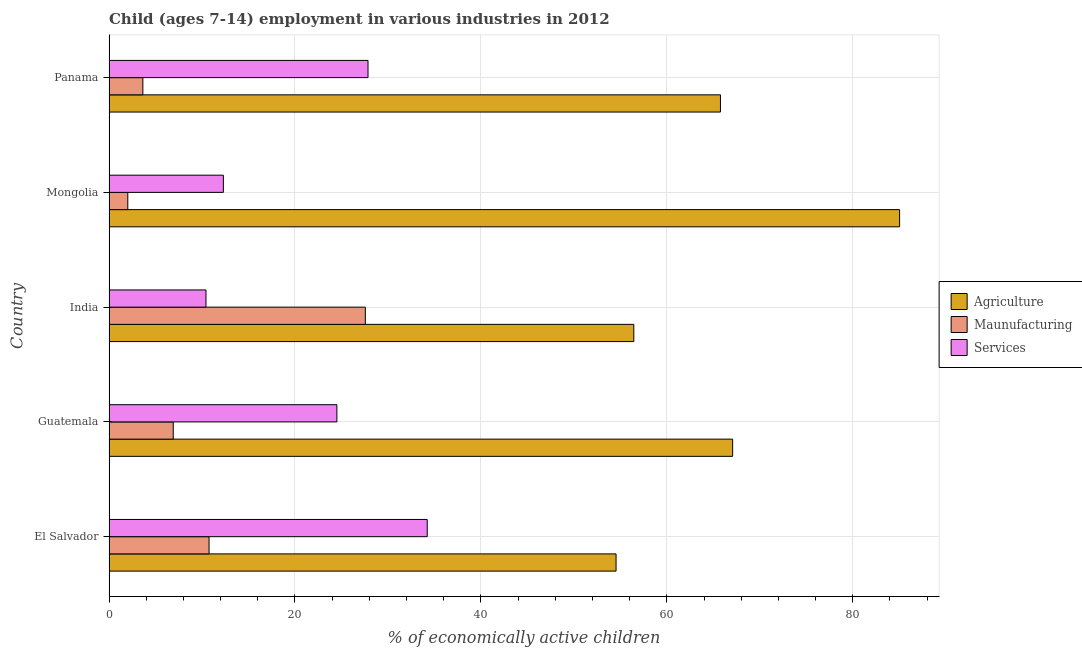How many groups of bars are there?
Your answer should be compact. 5. Are the number of bars per tick equal to the number of legend labels?
Provide a short and direct response. Yes. Are the number of bars on each tick of the Y-axis equal?
Offer a terse response. Yes. How many bars are there on the 1st tick from the top?
Make the answer very short. 3. How many bars are there on the 2nd tick from the bottom?
Provide a succinct answer. 3. What is the label of the 1st group of bars from the top?
Offer a terse response. Panama. In how many cases, is the number of bars for a given country not equal to the number of legend labels?
Offer a very short reply. 0. What is the percentage of economically active children in agriculture in Panama?
Your answer should be very brief. 65.77. Across all countries, what is the maximum percentage of economically active children in services?
Give a very brief answer. 34.23. Across all countries, what is the minimum percentage of economically active children in services?
Your response must be concise. 10.43. In which country was the percentage of economically active children in manufacturing maximum?
Your answer should be compact. India. In which country was the percentage of economically active children in services minimum?
Your answer should be compact. India. What is the total percentage of economically active children in agriculture in the graph?
Give a very brief answer. 328.88. What is the difference between the percentage of economically active children in services in India and that in Mongolia?
Your response must be concise. -1.87. What is the difference between the percentage of economically active children in services in Panama and the percentage of economically active children in manufacturing in Guatemala?
Your response must be concise. 20.95. What is the average percentage of economically active children in services per country?
Your answer should be compact. 21.87. What is the difference between the percentage of economically active children in agriculture and percentage of economically active children in manufacturing in India?
Provide a succinct answer. 28.88. In how many countries, is the percentage of economically active children in manufacturing greater than 36 %?
Offer a terse response. 0. What is the ratio of the percentage of economically active children in manufacturing in Guatemala to that in Panama?
Your answer should be compact. 1.9. Is the difference between the percentage of economically active children in agriculture in Guatemala and Mongolia greater than the difference between the percentage of economically active children in services in Guatemala and Mongolia?
Your answer should be very brief. No. What is the difference between the highest and the second highest percentage of economically active children in services?
Offer a very short reply. 6.37. What is the difference between the highest and the lowest percentage of economically active children in agriculture?
Your answer should be very brief. 30.5. In how many countries, is the percentage of economically active children in agriculture greater than the average percentage of economically active children in agriculture taken over all countries?
Offer a very short reply. 2. What does the 2nd bar from the top in Mongolia represents?
Provide a succinct answer. Maunufacturing. What does the 1st bar from the bottom in Guatemala represents?
Your response must be concise. Agriculture. Is it the case that in every country, the sum of the percentage of economically active children in agriculture and percentage of economically active children in manufacturing is greater than the percentage of economically active children in services?
Give a very brief answer. Yes. Are the values on the major ticks of X-axis written in scientific E-notation?
Your answer should be compact. No. Does the graph contain any zero values?
Your answer should be very brief. No. Does the graph contain grids?
Keep it short and to the point. Yes. Where does the legend appear in the graph?
Make the answer very short. Center right. How many legend labels are there?
Keep it short and to the point. 3. What is the title of the graph?
Make the answer very short. Child (ages 7-14) employment in various industries in 2012. Does "Coal" appear as one of the legend labels in the graph?
Give a very brief answer. No. What is the label or title of the X-axis?
Offer a terse response. % of economically active children. What is the label or title of the Y-axis?
Make the answer very short. Country. What is the % of economically active children of Agriculture in El Salvador?
Keep it short and to the point. 54.54. What is the % of economically active children in Maunufacturing in El Salvador?
Make the answer very short. 10.76. What is the % of economically active children in Services in El Salvador?
Offer a terse response. 34.23. What is the % of economically active children of Agriculture in Guatemala?
Keep it short and to the point. 67.08. What is the % of economically active children in Maunufacturing in Guatemala?
Give a very brief answer. 6.91. What is the % of economically active children in Services in Guatemala?
Provide a succinct answer. 24.51. What is the % of economically active children of Agriculture in India?
Ensure brevity in your answer.  56.45. What is the % of economically active children in Maunufacturing in India?
Ensure brevity in your answer.  27.57. What is the % of economically active children of Services in India?
Offer a very short reply. 10.43. What is the % of economically active children of Agriculture in Mongolia?
Your answer should be compact. 85.04. What is the % of economically active children of Maunufacturing in Mongolia?
Provide a succinct answer. 2.02. What is the % of economically active children in Services in Mongolia?
Make the answer very short. 12.3. What is the % of economically active children of Agriculture in Panama?
Offer a very short reply. 65.77. What is the % of economically active children in Maunufacturing in Panama?
Provide a succinct answer. 3.64. What is the % of economically active children in Services in Panama?
Give a very brief answer. 27.86. Across all countries, what is the maximum % of economically active children of Agriculture?
Your answer should be compact. 85.04. Across all countries, what is the maximum % of economically active children of Maunufacturing?
Provide a short and direct response. 27.57. Across all countries, what is the maximum % of economically active children in Services?
Ensure brevity in your answer.  34.23. Across all countries, what is the minimum % of economically active children in Agriculture?
Keep it short and to the point. 54.54. Across all countries, what is the minimum % of economically active children of Maunufacturing?
Provide a succinct answer. 2.02. Across all countries, what is the minimum % of economically active children of Services?
Your answer should be very brief. 10.43. What is the total % of economically active children of Agriculture in the graph?
Provide a short and direct response. 328.88. What is the total % of economically active children of Maunufacturing in the graph?
Give a very brief answer. 50.9. What is the total % of economically active children of Services in the graph?
Offer a terse response. 109.33. What is the difference between the % of economically active children in Agriculture in El Salvador and that in Guatemala?
Offer a terse response. -12.54. What is the difference between the % of economically active children in Maunufacturing in El Salvador and that in Guatemala?
Give a very brief answer. 3.85. What is the difference between the % of economically active children of Services in El Salvador and that in Guatemala?
Give a very brief answer. 9.72. What is the difference between the % of economically active children of Agriculture in El Salvador and that in India?
Make the answer very short. -1.91. What is the difference between the % of economically active children of Maunufacturing in El Salvador and that in India?
Your response must be concise. -16.81. What is the difference between the % of economically active children in Services in El Salvador and that in India?
Your answer should be compact. 23.8. What is the difference between the % of economically active children in Agriculture in El Salvador and that in Mongolia?
Ensure brevity in your answer.  -30.5. What is the difference between the % of economically active children of Maunufacturing in El Salvador and that in Mongolia?
Keep it short and to the point. 8.74. What is the difference between the % of economically active children of Services in El Salvador and that in Mongolia?
Keep it short and to the point. 21.93. What is the difference between the % of economically active children in Agriculture in El Salvador and that in Panama?
Offer a terse response. -11.23. What is the difference between the % of economically active children of Maunufacturing in El Salvador and that in Panama?
Your answer should be very brief. 7.12. What is the difference between the % of economically active children in Services in El Salvador and that in Panama?
Your answer should be very brief. 6.37. What is the difference between the % of economically active children of Agriculture in Guatemala and that in India?
Make the answer very short. 10.63. What is the difference between the % of economically active children in Maunufacturing in Guatemala and that in India?
Ensure brevity in your answer.  -20.66. What is the difference between the % of economically active children in Services in Guatemala and that in India?
Ensure brevity in your answer.  14.08. What is the difference between the % of economically active children in Agriculture in Guatemala and that in Mongolia?
Your response must be concise. -17.96. What is the difference between the % of economically active children of Maunufacturing in Guatemala and that in Mongolia?
Your response must be concise. 4.89. What is the difference between the % of economically active children of Services in Guatemala and that in Mongolia?
Offer a very short reply. 12.21. What is the difference between the % of economically active children in Agriculture in Guatemala and that in Panama?
Make the answer very short. 1.31. What is the difference between the % of economically active children of Maunufacturing in Guatemala and that in Panama?
Keep it short and to the point. 3.27. What is the difference between the % of economically active children in Services in Guatemala and that in Panama?
Keep it short and to the point. -3.35. What is the difference between the % of economically active children in Agriculture in India and that in Mongolia?
Provide a succinct answer. -28.59. What is the difference between the % of economically active children in Maunufacturing in India and that in Mongolia?
Offer a very short reply. 25.55. What is the difference between the % of economically active children in Services in India and that in Mongolia?
Keep it short and to the point. -1.87. What is the difference between the % of economically active children of Agriculture in India and that in Panama?
Your response must be concise. -9.32. What is the difference between the % of economically active children in Maunufacturing in India and that in Panama?
Give a very brief answer. 23.93. What is the difference between the % of economically active children in Services in India and that in Panama?
Give a very brief answer. -17.43. What is the difference between the % of economically active children in Agriculture in Mongolia and that in Panama?
Provide a short and direct response. 19.27. What is the difference between the % of economically active children of Maunufacturing in Mongolia and that in Panama?
Your answer should be compact. -1.62. What is the difference between the % of economically active children in Services in Mongolia and that in Panama?
Your answer should be very brief. -15.56. What is the difference between the % of economically active children of Agriculture in El Salvador and the % of economically active children of Maunufacturing in Guatemala?
Give a very brief answer. 47.63. What is the difference between the % of economically active children in Agriculture in El Salvador and the % of economically active children in Services in Guatemala?
Keep it short and to the point. 30.03. What is the difference between the % of economically active children in Maunufacturing in El Salvador and the % of economically active children in Services in Guatemala?
Your response must be concise. -13.75. What is the difference between the % of economically active children of Agriculture in El Salvador and the % of economically active children of Maunufacturing in India?
Your answer should be compact. 26.97. What is the difference between the % of economically active children of Agriculture in El Salvador and the % of economically active children of Services in India?
Keep it short and to the point. 44.11. What is the difference between the % of economically active children of Maunufacturing in El Salvador and the % of economically active children of Services in India?
Make the answer very short. 0.33. What is the difference between the % of economically active children of Agriculture in El Salvador and the % of economically active children of Maunufacturing in Mongolia?
Make the answer very short. 52.52. What is the difference between the % of economically active children in Agriculture in El Salvador and the % of economically active children in Services in Mongolia?
Your answer should be very brief. 42.24. What is the difference between the % of economically active children in Maunufacturing in El Salvador and the % of economically active children in Services in Mongolia?
Your answer should be compact. -1.54. What is the difference between the % of economically active children of Agriculture in El Salvador and the % of economically active children of Maunufacturing in Panama?
Provide a short and direct response. 50.9. What is the difference between the % of economically active children in Agriculture in El Salvador and the % of economically active children in Services in Panama?
Offer a very short reply. 26.68. What is the difference between the % of economically active children in Maunufacturing in El Salvador and the % of economically active children in Services in Panama?
Your answer should be compact. -17.1. What is the difference between the % of economically active children of Agriculture in Guatemala and the % of economically active children of Maunufacturing in India?
Keep it short and to the point. 39.51. What is the difference between the % of economically active children in Agriculture in Guatemala and the % of economically active children in Services in India?
Your answer should be compact. 56.65. What is the difference between the % of economically active children of Maunufacturing in Guatemala and the % of economically active children of Services in India?
Your answer should be very brief. -3.52. What is the difference between the % of economically active children in Agriculture in Guatemala and the % of economically active children in Maunufacturing in Mongolia?
Your answer should be very brief. 65.06. What is the difference between the % of economically active children in Agriculture in Guatemala and the % of economically active children in Services in Mongolia?
Keep it short and to the point. 54.78. What is the difference between the % of economically active children in Maunufacturing in Guatemala and the % of economically active children in Services in Mongolia?
Offer a terse response. -5.39. What is the difference between the % of economically active children of Agriculture in Guatemala and the % of economically active children of Maunufacturing in Panama?
Keep it short and to the point. 63.44. What is the difference between the % of economically active children of Agriculture in Guatemala and the % of economically active children of Services in Panama?
Offer a very short reply. 39.22. What is the difference between the % of economically active children of Maunufacturing in Guatemala and the % of economically active children of Services in Panama?
Your answer should be compact. -20.95. What is the difference between the % of economically active children in Agriculture in India and the % of economically active children in Maunufacturing in Mongolia?
Keep it short and to the point. 54.43. What is the difference between the % of economically active children in Agriculture in India and the % of economically active children in Services in Mongolia?
Provide a short and direct response. 44.15. What is the difference between the % of economically active children of Maunufacturing in India and the % of economically active children of Services in Mongolia?
Ensure brevity in your answer.  15.27. What is the difference between the % of economically active children in Agriculture in India and the % of economically active children in Maunufacturing in Panama?
Offer a terse response. 52.81. What is the difference between the % of economically active children of Agriculture in India and the % of economically active children of Services in Panama?
Ensure brevity in your answer.  28.59. What is the difference between the % of economically active children of Maunufacturing in India and the % of economically active children of Services in Panama?
Keep it short and to the point. -0.29. What is the difference between the % of economically active children of Agriculture in Mongolia and the % of economically active children of Maunufacturing in Panama?
Provide a succinct answer. 81.4. What is the difference between the % of economically active children of Agriculture in Mongolia and the % of economically active children of Services in Panama?
Your answer should be compact. 57.18. What is the difference between the % of economically active children of Maunufacturing in Mongolia and the % of economically active children of Services in Panama?
Offer a terse response. -25.84. What is the average % of economically active children of Agriculture per country?
Give a very brief answer. 65.78. What is the average % of economically active children in Maunufacturing per country?
Your answer should be very brief. 10.18. What is the average % of economically active children of Services per country?
Provide a short and direct response. 21.87. What is the difference between the % of economically active children in Agriculture and % of economically active children in Maunufacturing in El Salvador?
Ensure brevity in your answer.  43.78. What is the difference between the % of economically active children in Agriculture and % of economically active children in Services in El Salvador?
Provide a short and direct response. 20.31. What is the difference between the % of economically active children of Maunufacturing and % of economically active children of Services in El Salvador?
Provide a succinct answer. -23.47. What is the difference between the % of economically active children of Agriculture and % of economically active children of Maunufacturing in Guatemala?
Provide a succinct answer. 60.17. What is the difference between the % of economically active children in Agriculture and % of economically active children in Services in Guatemala?
Provide a succinct answer. 42.57. What is the difference between the % of economically active children in Maunufacturing and % of economically active children in Services in Guatemala?
Offer a terse response. -17.6. What is the difference between the % of economically active children of Agriculture and % of economically active children of Maunufacturing in India?
Provide a succinct answer. 28.88. What is the difference between the % of economically active children in Agriculture and % of economically active children in Services in India?
Offer a terse response. 46.02. What is the difference between the % of economically active children of Maunufacturing and % of economically active children of Services in India?
Keep it short and to the point. 17.14. What is the difference between the % of economically active children in Agriculture and % of economically active children in Maunufacturing in Mongolia?
Ensure brevity in your answer.  83.02. What is the difference between the % of economically active children of Agriculture and % of economically active children of Services in Mongolia?
Offer a very short reply. 72.74. What is the difference between the % of economically active children in Maunufacturing and % of economically active children in Services in Mongolia?
Make the answer very short. -10.28. What is the difference between the % of economically active children of Agriculture and % of economically active children of Maunufacturing in Panama?
Your answer should be very brief. 62.13. What is the difference between the % of economically active children in Agriculture and % of economically active children in Services in Panama?
Give a very brief answer. 37.91. What is the difference between the % of economically active children in Maunufacturing and % of economically active children in Services in Panama?
Provide a short and direct response. -24.22. What is the ratio of the % of economically active children in Agriculture in El Salvador to that in Guatemala?
Provide a short and direct response. 0.81. What is the ratio of the % of economically active children in Maunufacturing in El Salvador to that in Guatemala?
Make the answer very short. 1.56. What is the ratio of the % of economically active children in Services in El Salvador to that in Guatemala?
Your answer should be very brief. 1.4. What is the ratio of the % of economically active children of Agriculture in El Salvador to that in India?
Make the answer very short. 0.97. What is the ratio of the % of economically active children of Maunufacturing in El Salvador to that in India?
Your response must be concise. 0.39. What is the ratio of the % of economically active children of Services in El Salvador to that in India?
Keep it short and to the point. 3.28. What is the ratio of the % of economically active children in Agriculture in El Salvador to that in Mongolia?
Offer a very short reply. 0.64. What is the ratio of the % of economically active children of Maunufacturing in El Salvador to that in Mongolia?
Your answer should be compact. 5.33. What is the ratio of the % of economically active children of Services in El Salvador to that in Mongolia?
Offer a terse response. 2.78. What is the ratio of the % of economically active children in Agriculture in El Salvador to that in Panama?
Make the answer very short. 0.83. What is the ratio of the % of economically active children of Maunufacturing in El Salvador to that in Panama?
Provide a succinct answer. 2.96. What is the ratio of the % of economically active children of Services in El Salvador to that in Panama?
Your response must be concise. 1.23. What is the ratio of the % of economically active children of Agriculture in Guatemala to that in India?
Your response must be concise. 1.19. What is the ratio of the % of economically active children of Maunufacturing in Guatemala to that in India?
Your answer should be very brief. 0.25. What is the ratio of the % of economically active children in Services in Guatemala to that in India?
Your response must be concise. 2.35. What is the ratio of the % of economically active children of Agriculture in Guatemala to that in Mongolia?
Keep it short and to the point. 0.79. What is the ratio of the % of economically active children of Maunufacturing in Guatemala to that in Mongolia?
Offer a very short reply. 3.42. What is the ratio of the % of economically active children in Services in Guatemala to that in Mongolia?
Your response must be concise. 1.99. What is the ratio of the % of economically active children in Agriculture in Guatemala to that in Panama?
Ensure brevity in your answer.  1.02. What is the ratio of the % of economically active children of Maunufacturing in Guatemala to that in Panama?
Give a very brief answer. 1.9. What is the ratio of the % of economically active children of Services in Guatemala to that in Panama?
Make the answer very short. 0.88. What is the ratio of the % of economically active children in Agriculture in India to that in Mongolia?
Provide a short and direct response. 0.66. What is the ratio of the % of economically active children in Maunufacturing in India to that in Mongolia?
Keep it short and to the point. 13.65. What is the ratio of the % of economically active children in Services in India to that in Mongolia?
Make the answer very short. 0.85. What is the ratio of the % of economically active children of Agriculture in India to that in Panama?
Your answer should be very brief. 0.86. What is the ratio of the % of economically active children of Maunufacturing in India to that in Panama?
Keep it short and to the point. 7.57. What is the ratio of the % of economically active children in Services in India to that in Panama?
Offer a terse response. 0.37. What is the ratio of the % of economically active children of Agriculture in Mongolia to that in Panama?
Make the answer very short. 1.29. What is the ratio of the % of economically active children in Maunufacturing in Mongolia to that in Panama?
Ensure brevity in your answer.  0.55. What is the ratio of the % of economically active children in Services in Mongolia to that in Panama?
Provide a succinct answer. 0.44. What is the difference between the highest and the second highest % of economically active children of Agriculture?
Provide a succinct answer. 17.96. What is the difference between the highest and the second highest % of economically active children in Maunufacturing?
Give a very brief answer. 16.81. What is the difference between the highest and the second highest % of economically active children of Services?
Provide a short and direct response. 6.37. What is the difference between the highest and the lowest % of economically active children in Agriculture?
Your response must be concise. 30.5. What is the difference between the highest and the lowest % of economically active children in Maunufacturing?
Ensure brevity in your answer.  25.55. What is the difference between the highest and the lowest % of economically active children of Services?
Your answer should be compact. 23.8. 